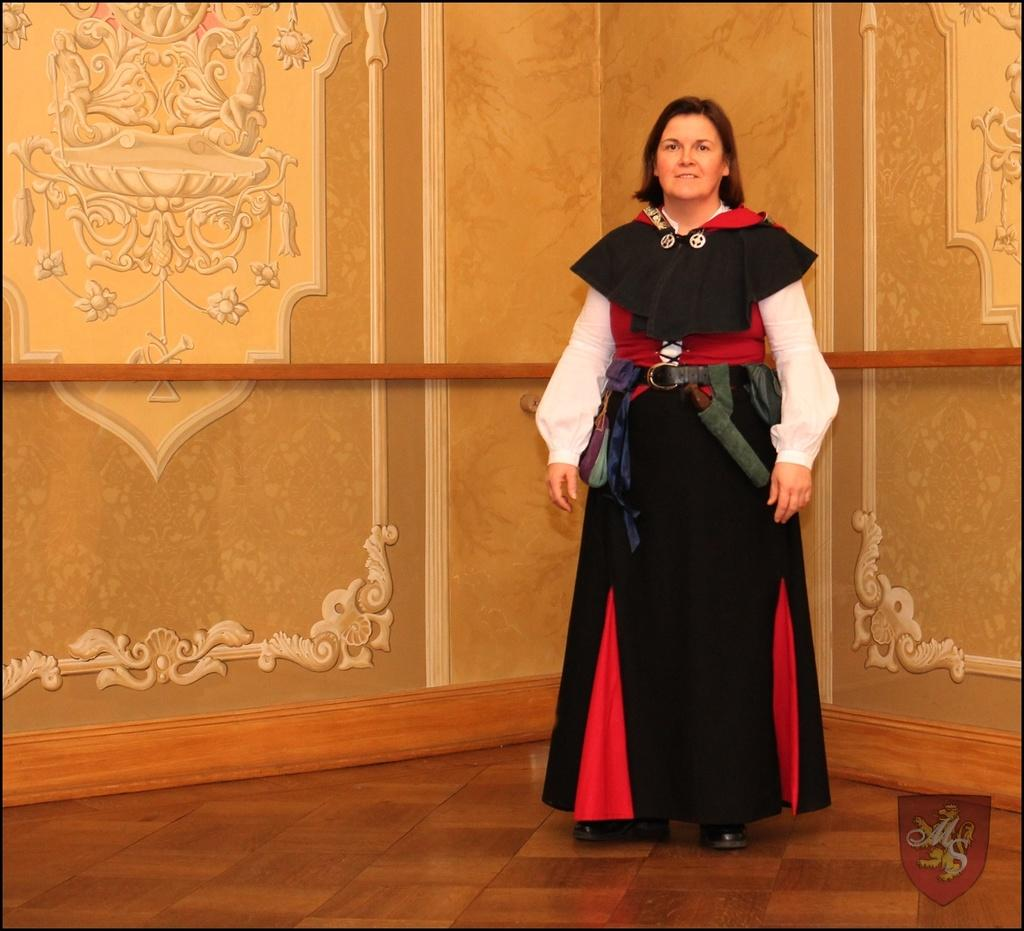Who is present in the image? There is a woman in the image. What is the woman doing in the image? The woman is standing on the floor and smiling. What can be seen in the background of the image? There is a wall in the background of the image. Where is the expert gardening in the image? There is no expert gardening in the image, nor is there a garden or lake present. 